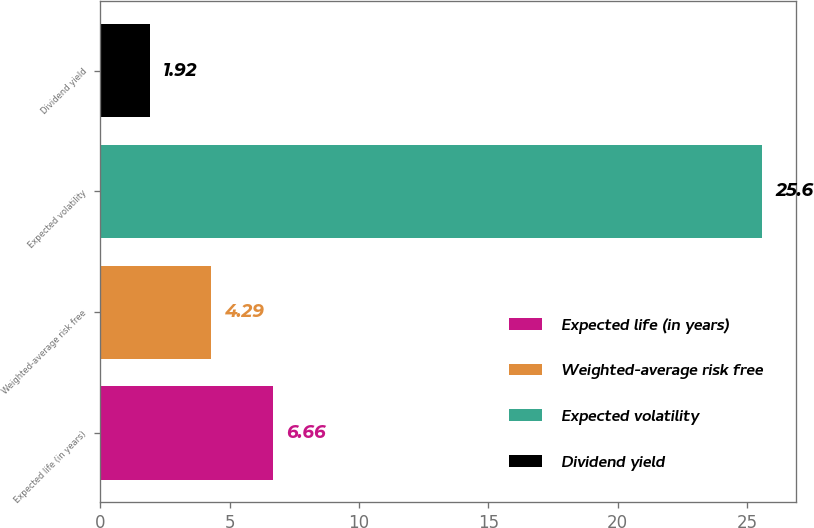Convert chart to OTSL. <chart><loc_0><loc_0><loc_500><loc_500><bar_chart><fcel>Expected life (in years)<fcel>Weighted-average risk free<fcel>Expected volatility<fcel>Dividend yield<nl><fcel>6.66<fcel>4.29<fcel>25.6<fcel>1.92<nl></chart> 